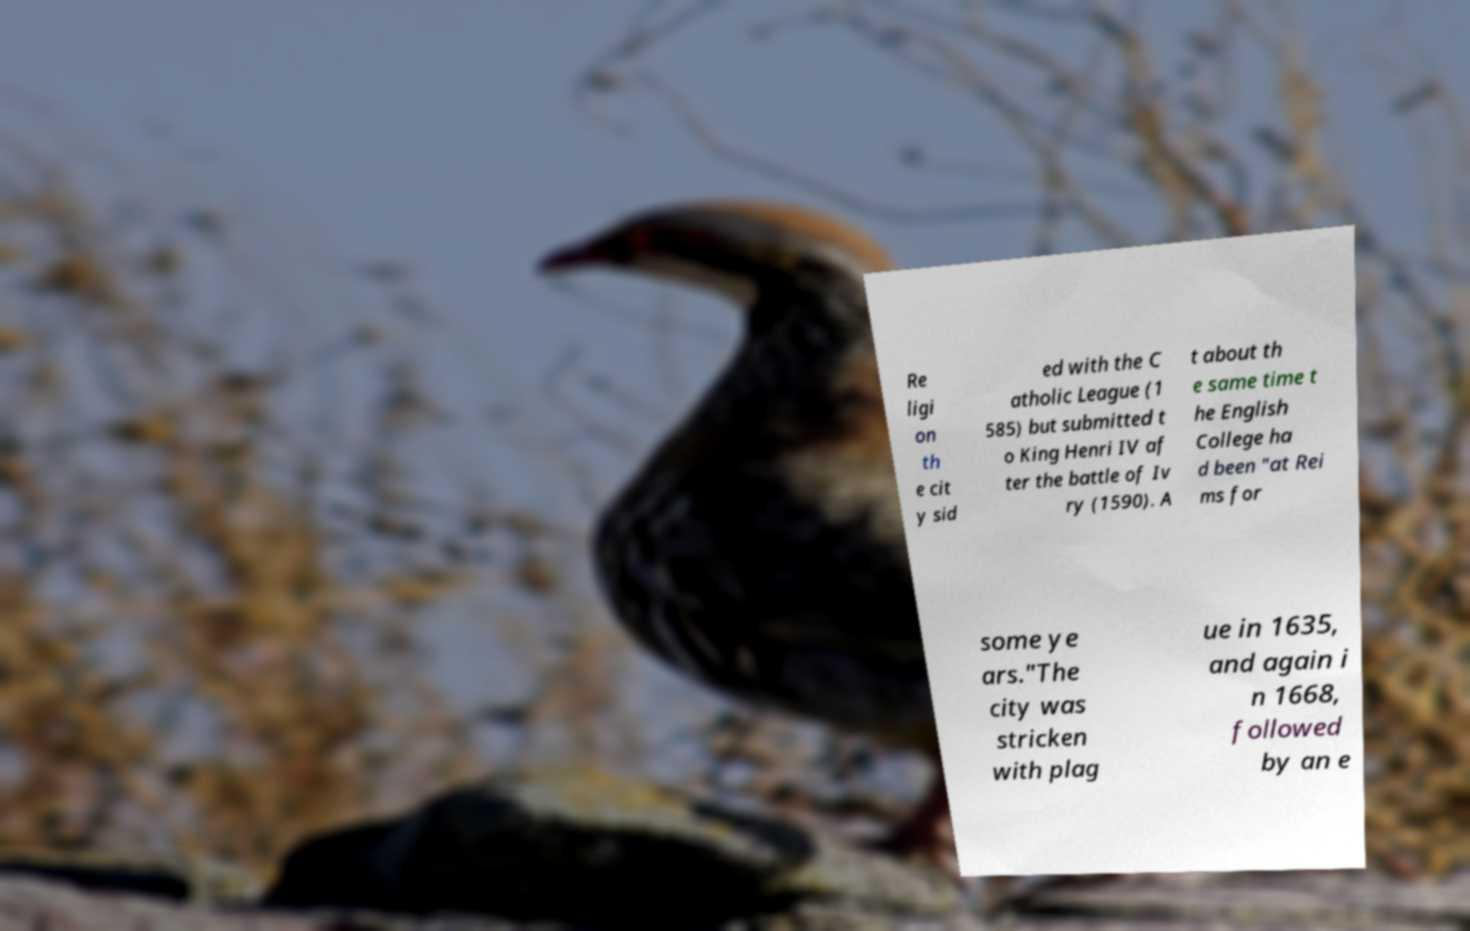Please identify and transcribe the text found in this image. Re ligi on th e cit y sid ed with the C atholic League (1 585) but submitted t o King Henri IV af ter the battle of Iv ry (1590). A t about th e same time t he English College ha d been "at Rei ms for some ye ars."The city was stricken with plag ue in 1635, and again i n 1668, followed by an e 